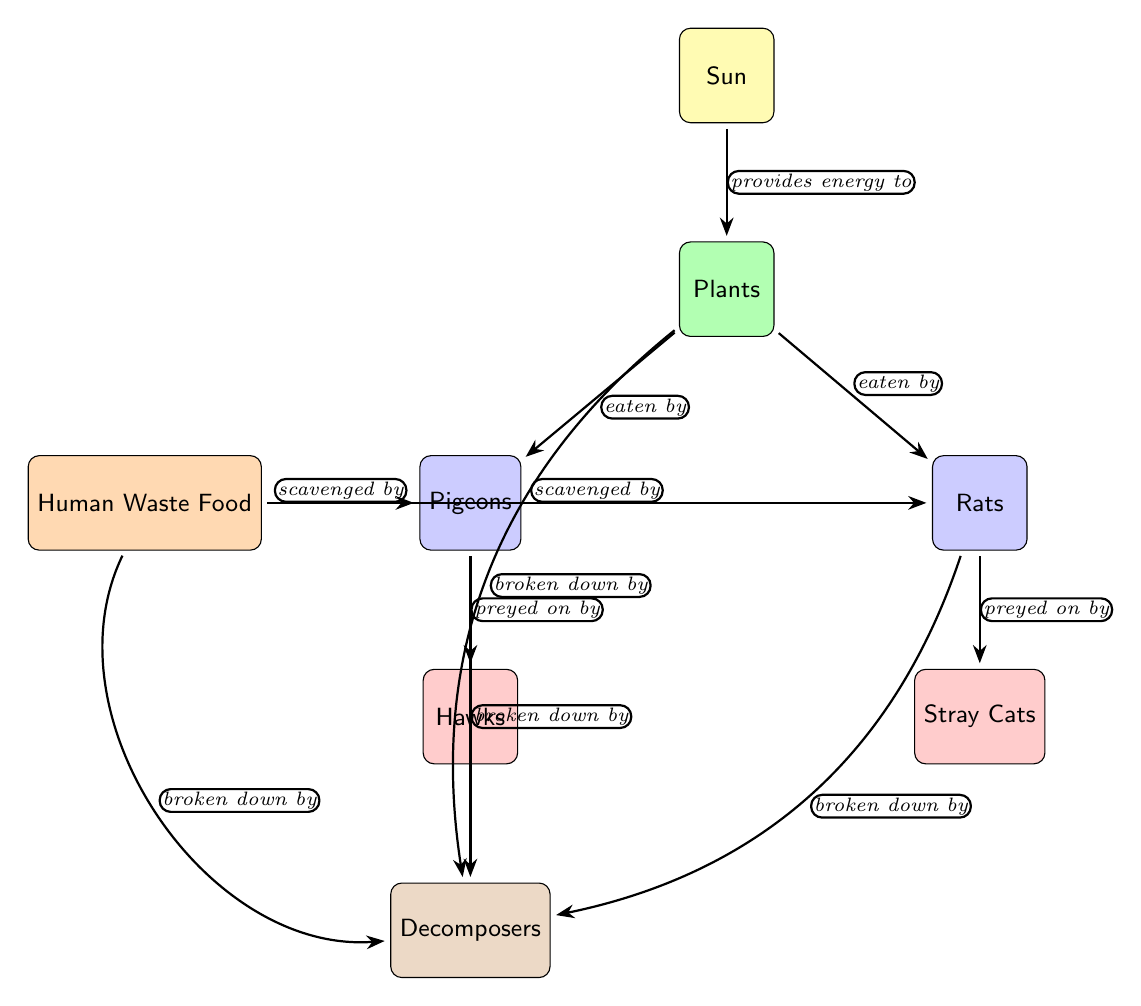What is the energy source for this food web? The diagram shows that the Sun is the primary energy source for the food web, as indicated at the top of the diagram.
Answer: Sun How many primary consumers are in the diagram? The diagram lists two primary consumers: Pigeons and Rats, which are both labeled as such in the food web.
Answer: 2 What do pigeons and rats scavenge for? According to the diagram, both Pigeons and Rats scavenge for Human Waste Food. This relationship is denoted by the edges leading from the waste food to both consumers.
Answer: Human Waste Food Who preys on the pigeons? The diagram depicts Hawks as the secondary consumer that preys on the Pigeons, indicated by the directional edge connecting the two.
Answer: Hawks Which organisms are broken down by decomposers? Decomposers break down Plants, Waste Food, Pigeons, and Rats, as shown by the connections leading from each of these items to the Decomposers node.
Answer: Plants, Waste Food, Pigeons, Rats What type of organism is a rat in this food chain? In this food web, a Rat is categorized as a primary consumer, as indicated by the color code and label in the diagram.
Answer: Primary consumer How many secondary consumers are there? The diagram shows two secondary consumers: Hawks and Stray Cats, as labeled in their respective nodes.
Answer: 2 What role does the Sun play in this food web? The Sun provides energy to the Plants, which are the producers in this food web, illustrated by the edge connecting the Sun to Plants.
Answer: Provides energy What relationships are shown as scavenging in the diagram? The scavenging relationships indicated in the diagram are between Humans Waste Food and both Pigeons and Rats, represented by the arrows pointing towards the consumers.
Answer: Scavenging by Pigeons and Rats 